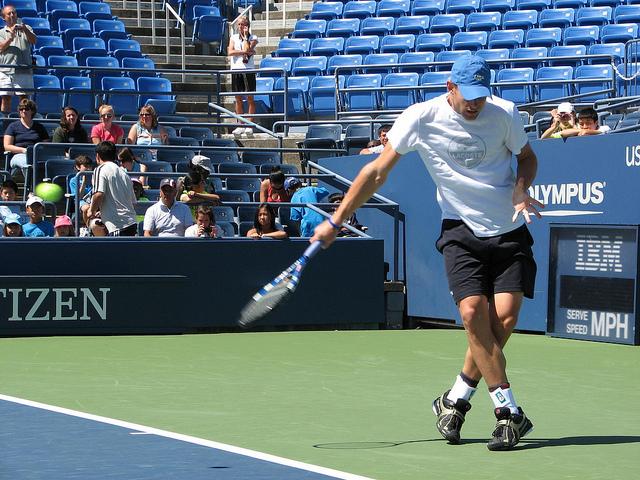How many fans in the stands?
Write a very short answer. 20. Which wrist has a blue band?
Give a very brief answer. Right. What color are the seats?
Concise answer only. Blue. What is in the guys left hand?
Concise answer only. Ball. 